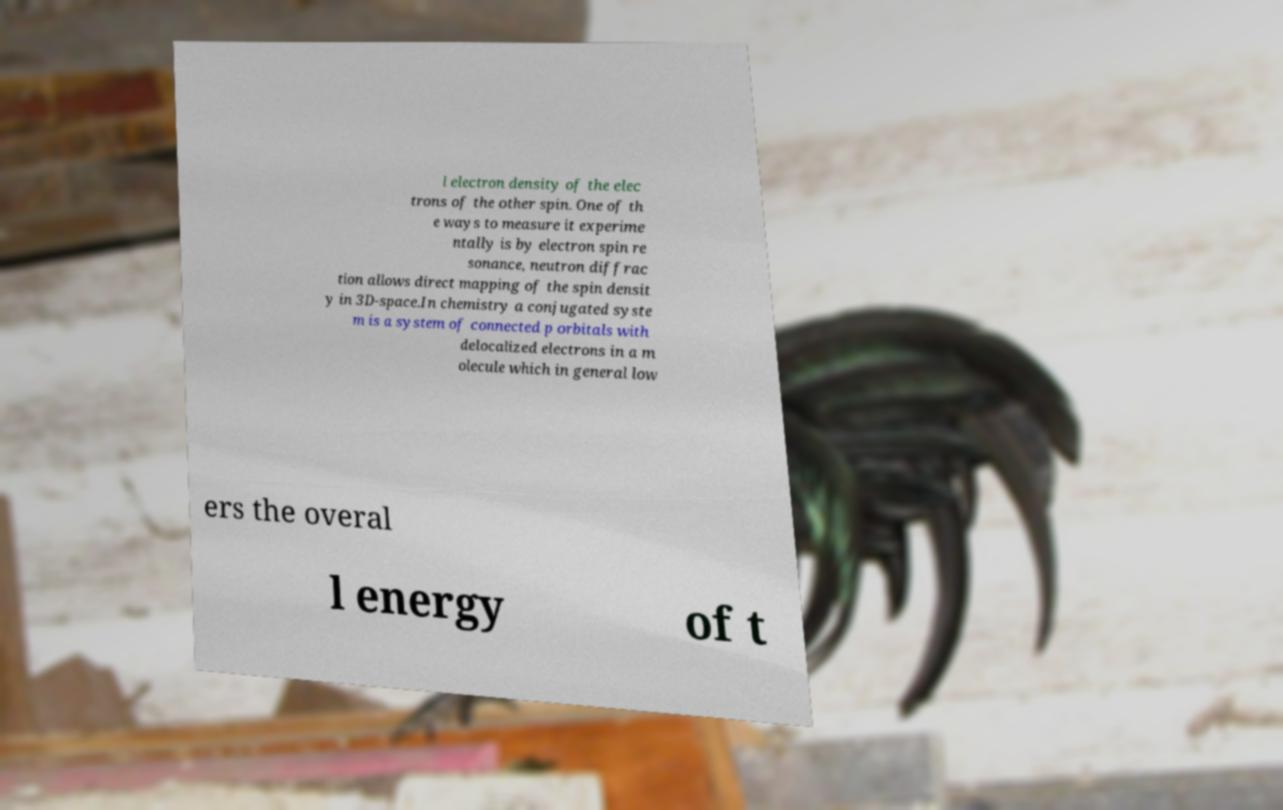I need the written content from this picture converted into text. Can you do that? l electron density of the elec trons of the other spin. One of th e ways to measure it experime ntally is by electron spin re sonance, neutron diffrac tion allows direct mapping of the spin densit y in 3D-space.In chemistry a conjugated syste m is a system of connected p orbitals with delocalized electrons in a m olecule which in general low ers the overal l energy of t 